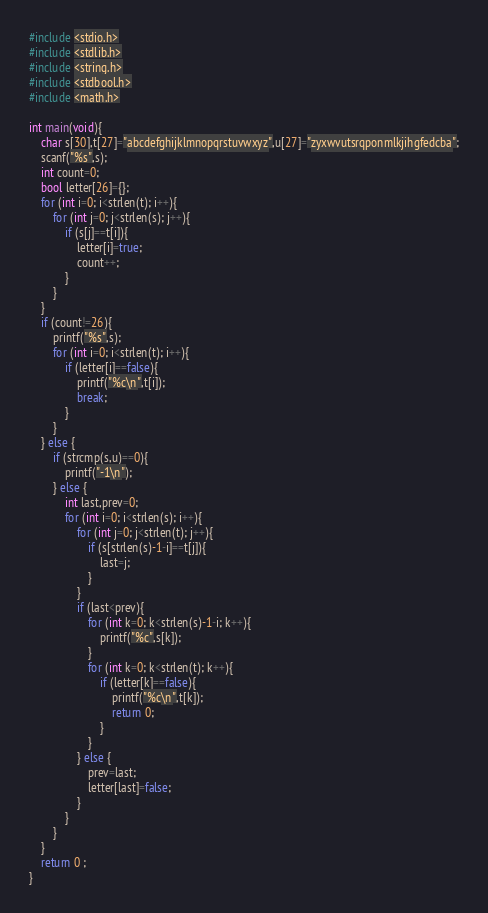<code> <loc_0><loc_0><loc_500><loc_500><_C_>#include <stdio.h>
#include <stdlib.h>
#include <string.h>
#include <stdbool.h>
#include <math.h>

int main(void){
    char s[30],t[27]="abcdefghijklmnopqrstuvwxyz",u[27]="zyxwvutsrqponmlkjihgfedcba";
    scanf("%s",s);
    int count=0;
    bool letter[26]={};
    for (int i=0; i<strlen(t); i++){
        for (int j=0; j<strlen(s); j++){
            if (s[j]==t[i]){
                letter[i]=true;
                count++;
            }
        }
    }
    if (count!=26){
        printf("%s",s);
        for (int i=0; i<strlen(t); i++){
            if (letter[i]==false){
                printf("%c\n",t[i]);
                break;
            }
        }
    } else {
        if (strcmp(s,u)==0){
            printf("-1\n");
        } else {
            int last,prev=0;
            for (int i=0; i<strlen(s); i++){
                for (int j=0; j<strlen(t); j++){
                    if (s[strlen(s)-1-i]==t[j]){
                        last=j;
                    }
                }
                if (last<prev){
                    for (int k=0; k<strlen(s)-1-i; k++){
                        printf("%c",s[k]);
                    }
                    for (int k=0; k<strlen(t); k++){
                        if (letter[k]==false){
                            printf("%c\n",t[k]);
                            return 0;
                        }
                    }
                } else {
                    prev=last;
                    letter[last]=false;
                }
            }
        }
    }
	return 0 ;
}</code> 